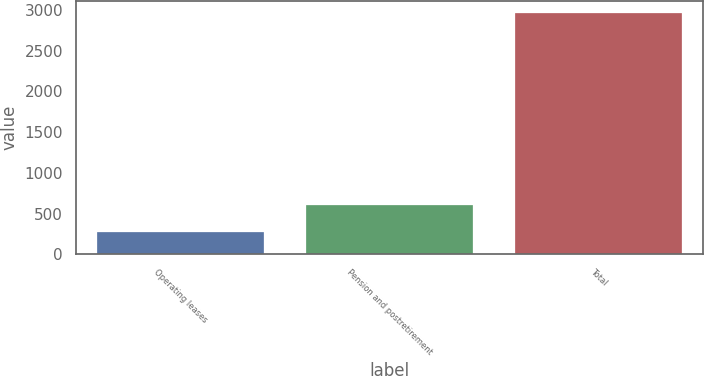Convert chart to OTSL. <chart><loc_0><loc_0><loc_500><loc_500><bar_chart><fcel>Operating leases<fcel>Pension and postretirement<fcel>Total<nl><fcel>273.2<fcel>601.4<fcel>2962.7<nl></chart> 